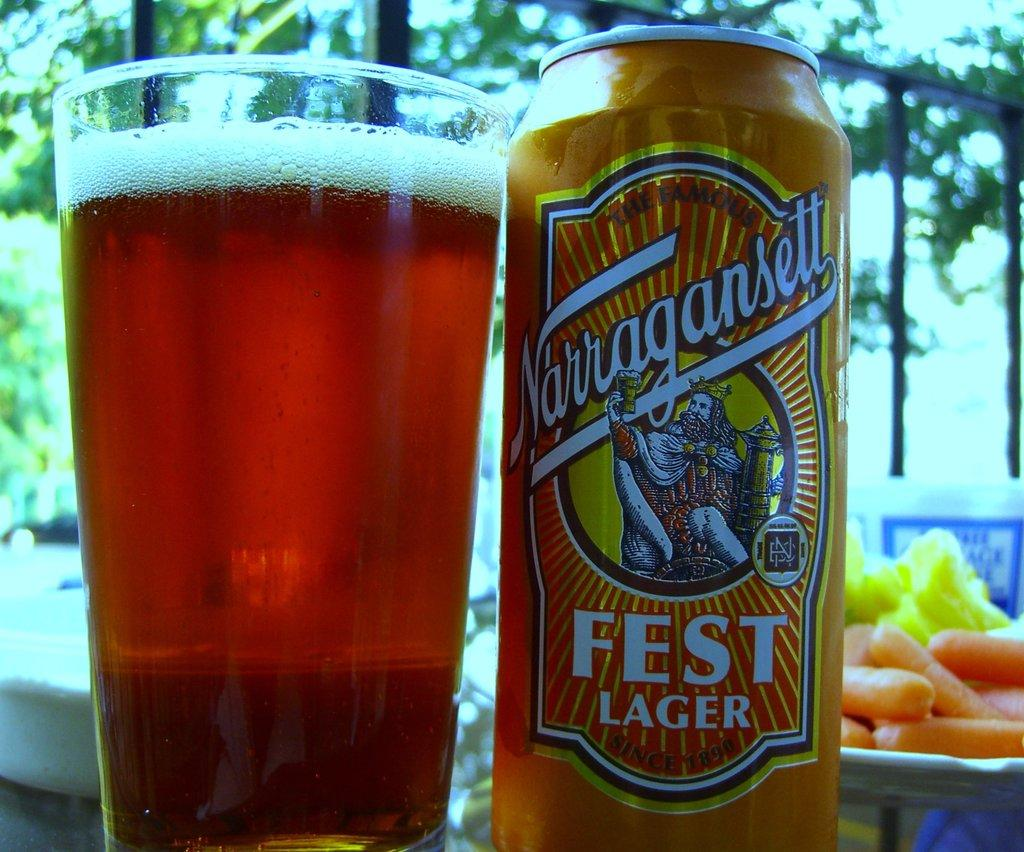<image>
Provide a brief description of the given image. A can of Norragansell Fest Lager and a glass of beer. 